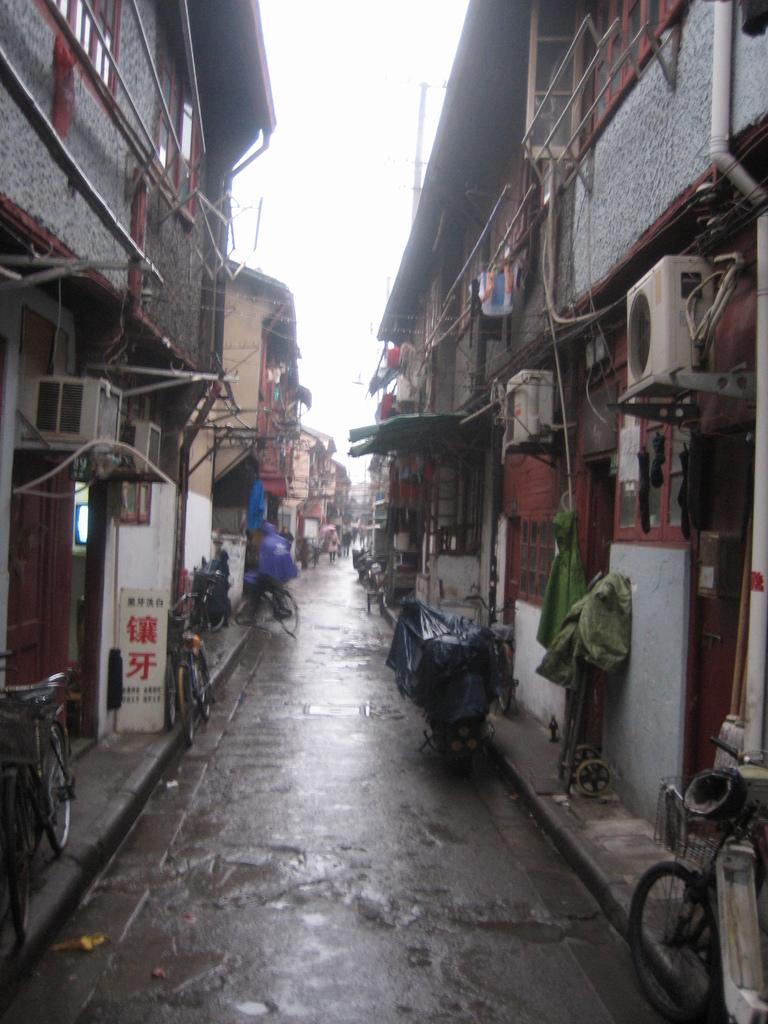What type of vehicles are on the road in the image? There are bicycles on the road in the image. Where are the bicycles located in the image? The bicycles are at the bottom of the image. What can be seen in the background of the image? There are buildings in the background of the image. What is visible at the top of the image? The sky is visible at the top of the image. What type of stamp can be seen on the bicycles in the image? There is no stamp present on the bicycles in the image. 